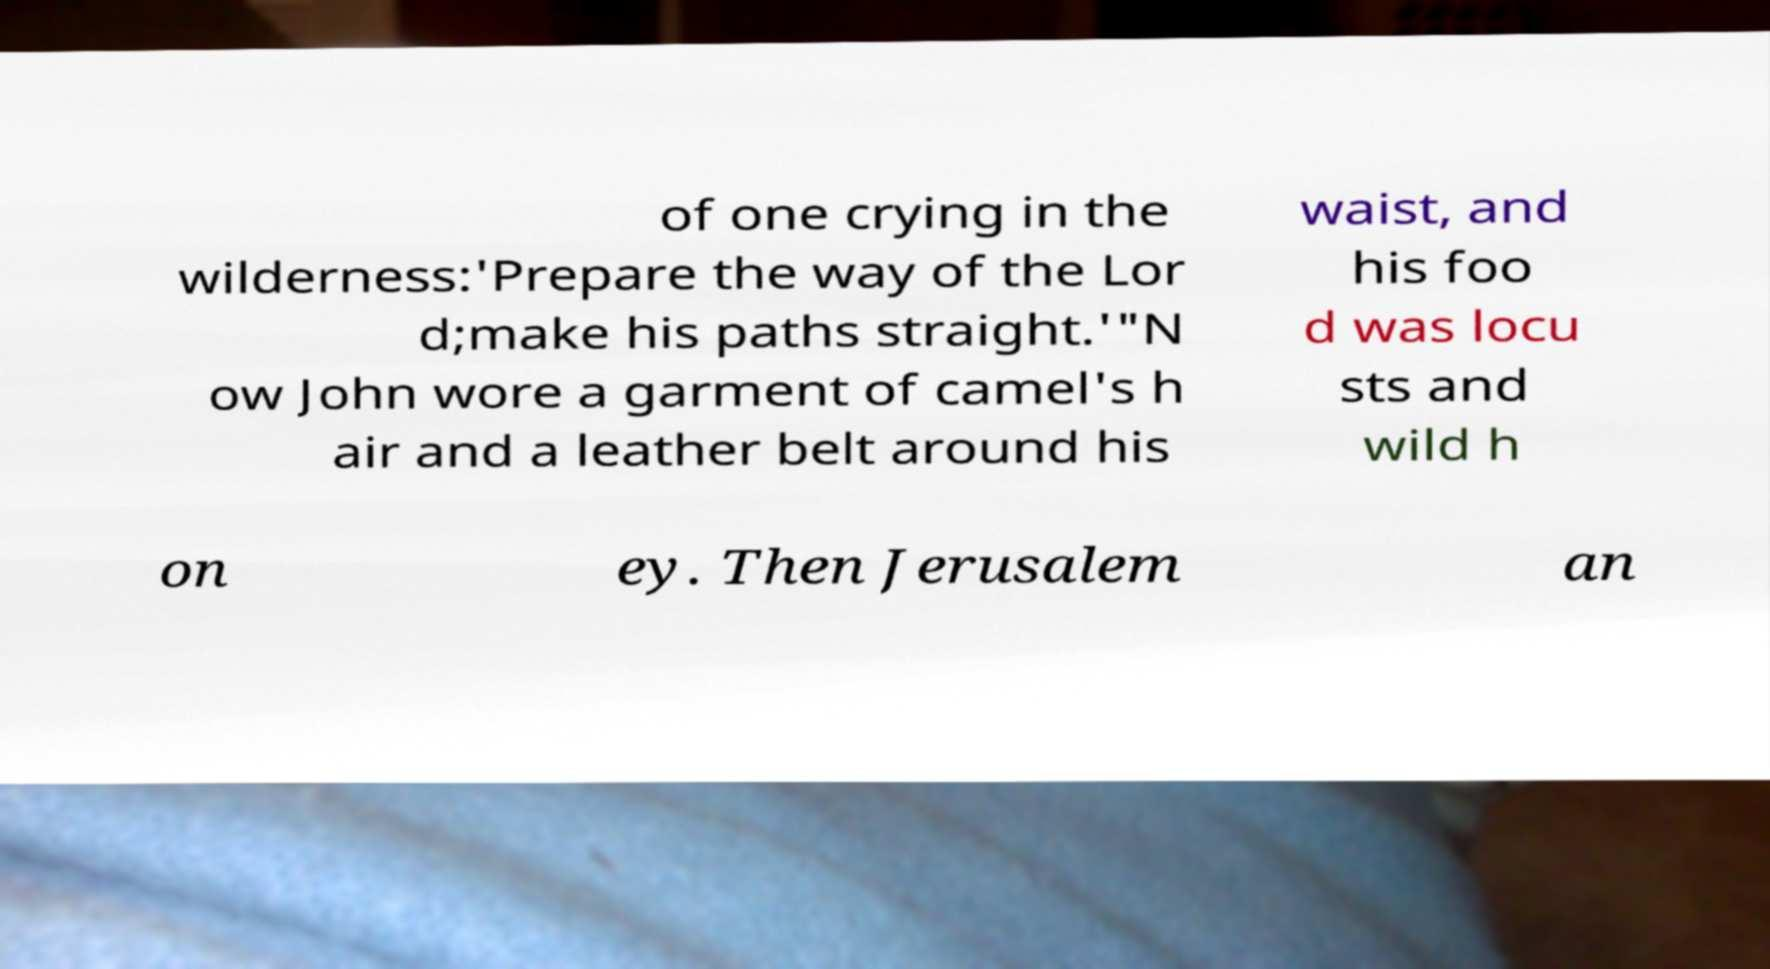Can you read and provide the text displayed in the image?This photo seems to have some interesting text. Can you extract and type it out for me? of one crying in the wilderness:'Prepare the way of the Lor d;make his paths straight.'"N ow John wore a garment of camel's h air and a leather belt around his waist, and his foo d was locu sts and wild h on ey. Then Jerusalem an 